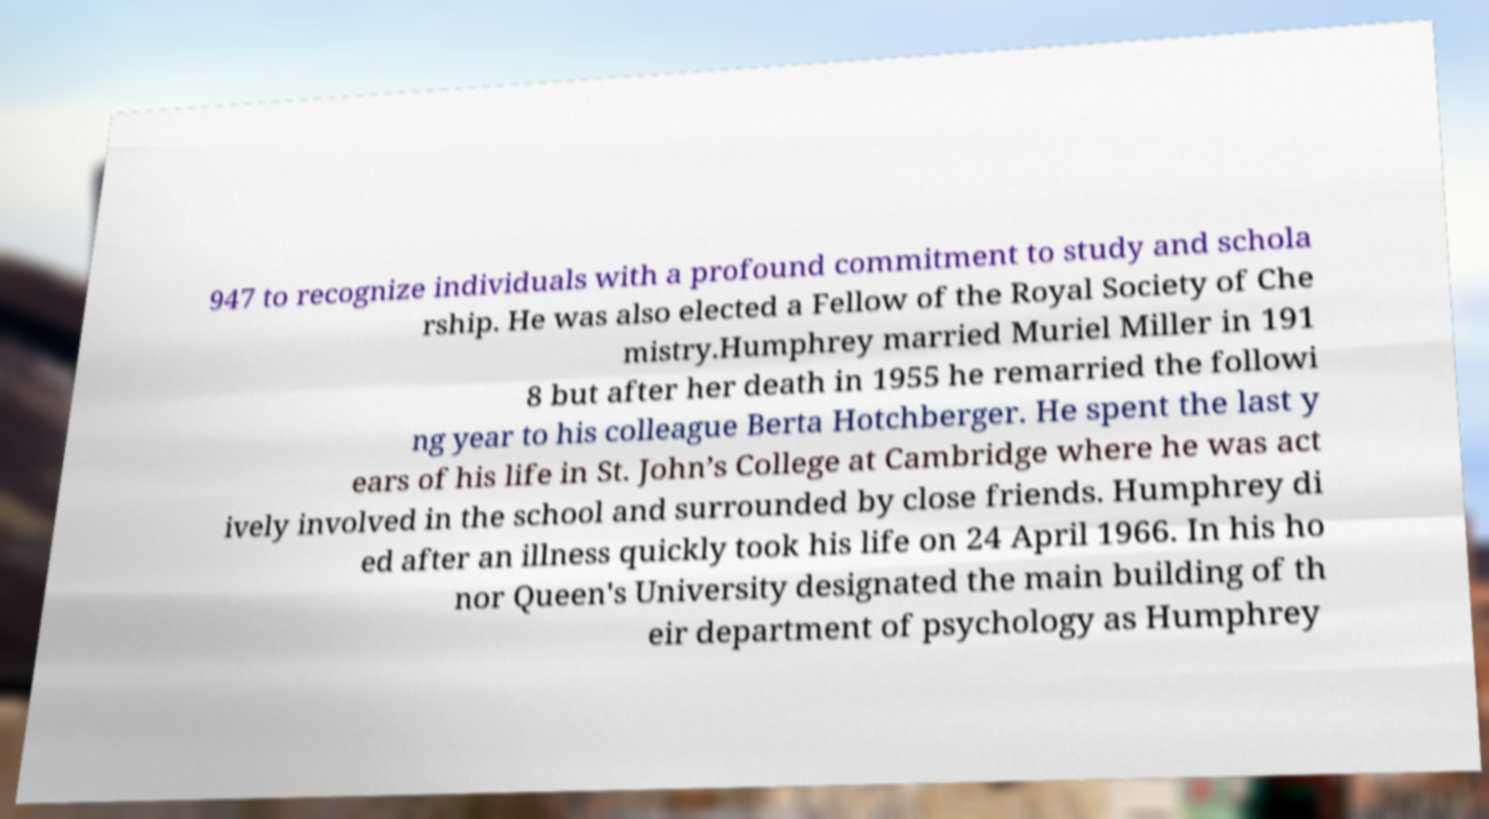What messages or text are displayed in this image? I need them in a readable, typed format. 947 to recognize individuals with a profound commitment to study and schola rship. He was also elected a Fellow of the Royal Society of Che mistry.Humphrey married Muriel Miller in 191 8 but after her death in 1955 he remarried the followi ng year to his colleague Berta Hotchberger. He spent the last y ears of his life in St. John’s College at Cambridge where he was act ively involved in the school and surrounded by close friends. Humphrey di ed after an illness quickly took his life on 24 April 1966. In his ho nor Queen's University designated the main building of th eir department of psychology as Humphrey 